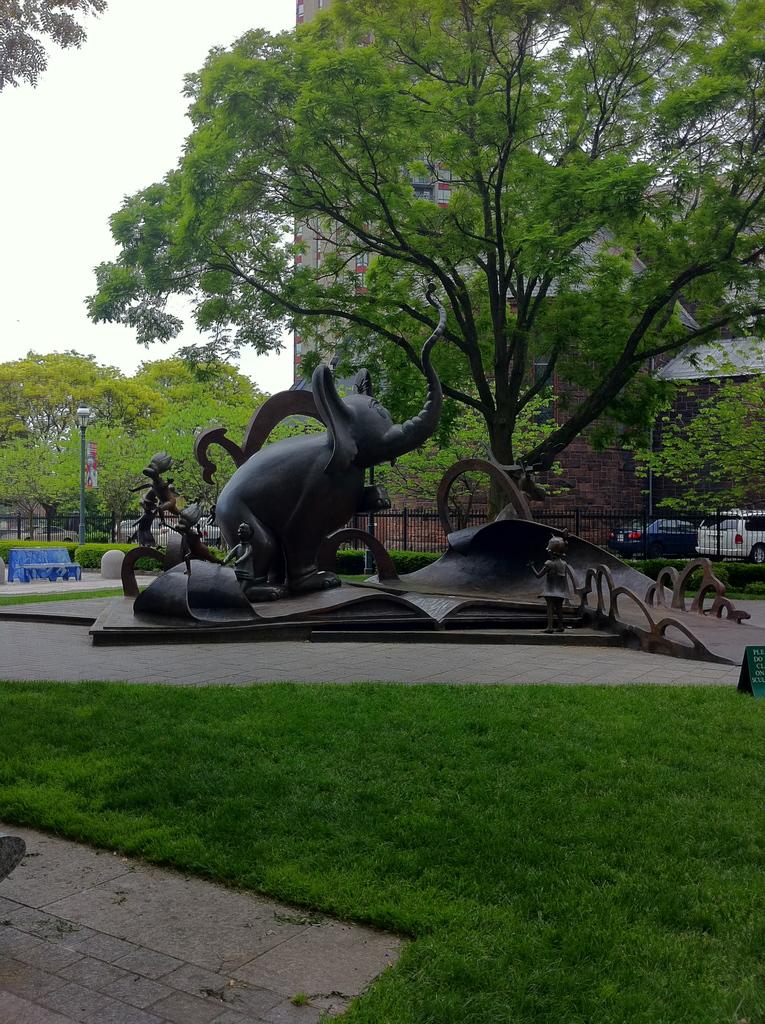What is the main subject in the center of the image? There is a sculpture in the center of the image. What type of vegetation is present at the bottom of the image? There is grass at the bottom of the image. What can be seen in the background of the image? There is a fence, trees, a building, cars, and the sky visible in the background of the image. Where is the bench located in the image? The bench is on the left side of the image. How many pies are on the bench in the image? There are no pies present on the bench in the image. What type of squirrel can be seen climbing the sculpture in the image? There is no squirrel present in the image, and therefore no such activity can be observed. 